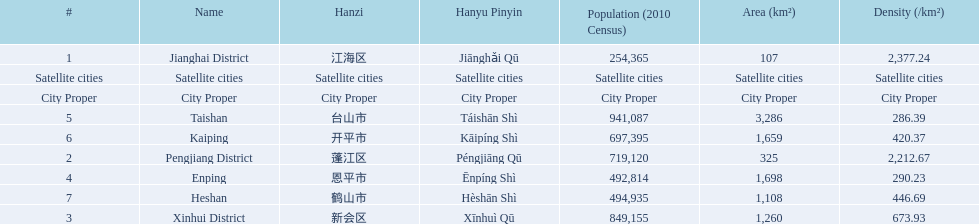What city propers are listed? Jianghai District, Pengjiang District, Xinhui District. Which hast he smallest area in km2? Jianghai District. 